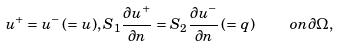Convert formula to latex. <formula><loc_0><loc_0><loc_500><loc_500>u ^ { + } = u ^ { - } \, ( = u ) , S _ { 1 } \frac { \partial u ^ { + } } { \partial n } = S _ { 2 } \frac { \partial u ^ { - } } { \partial n } \, ( = q ) \quad o n \partial \Omega ,</formula> 